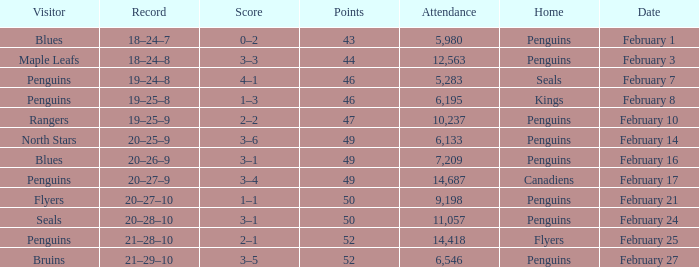Record of 21–29–10 had what total number of points? 1.0. 